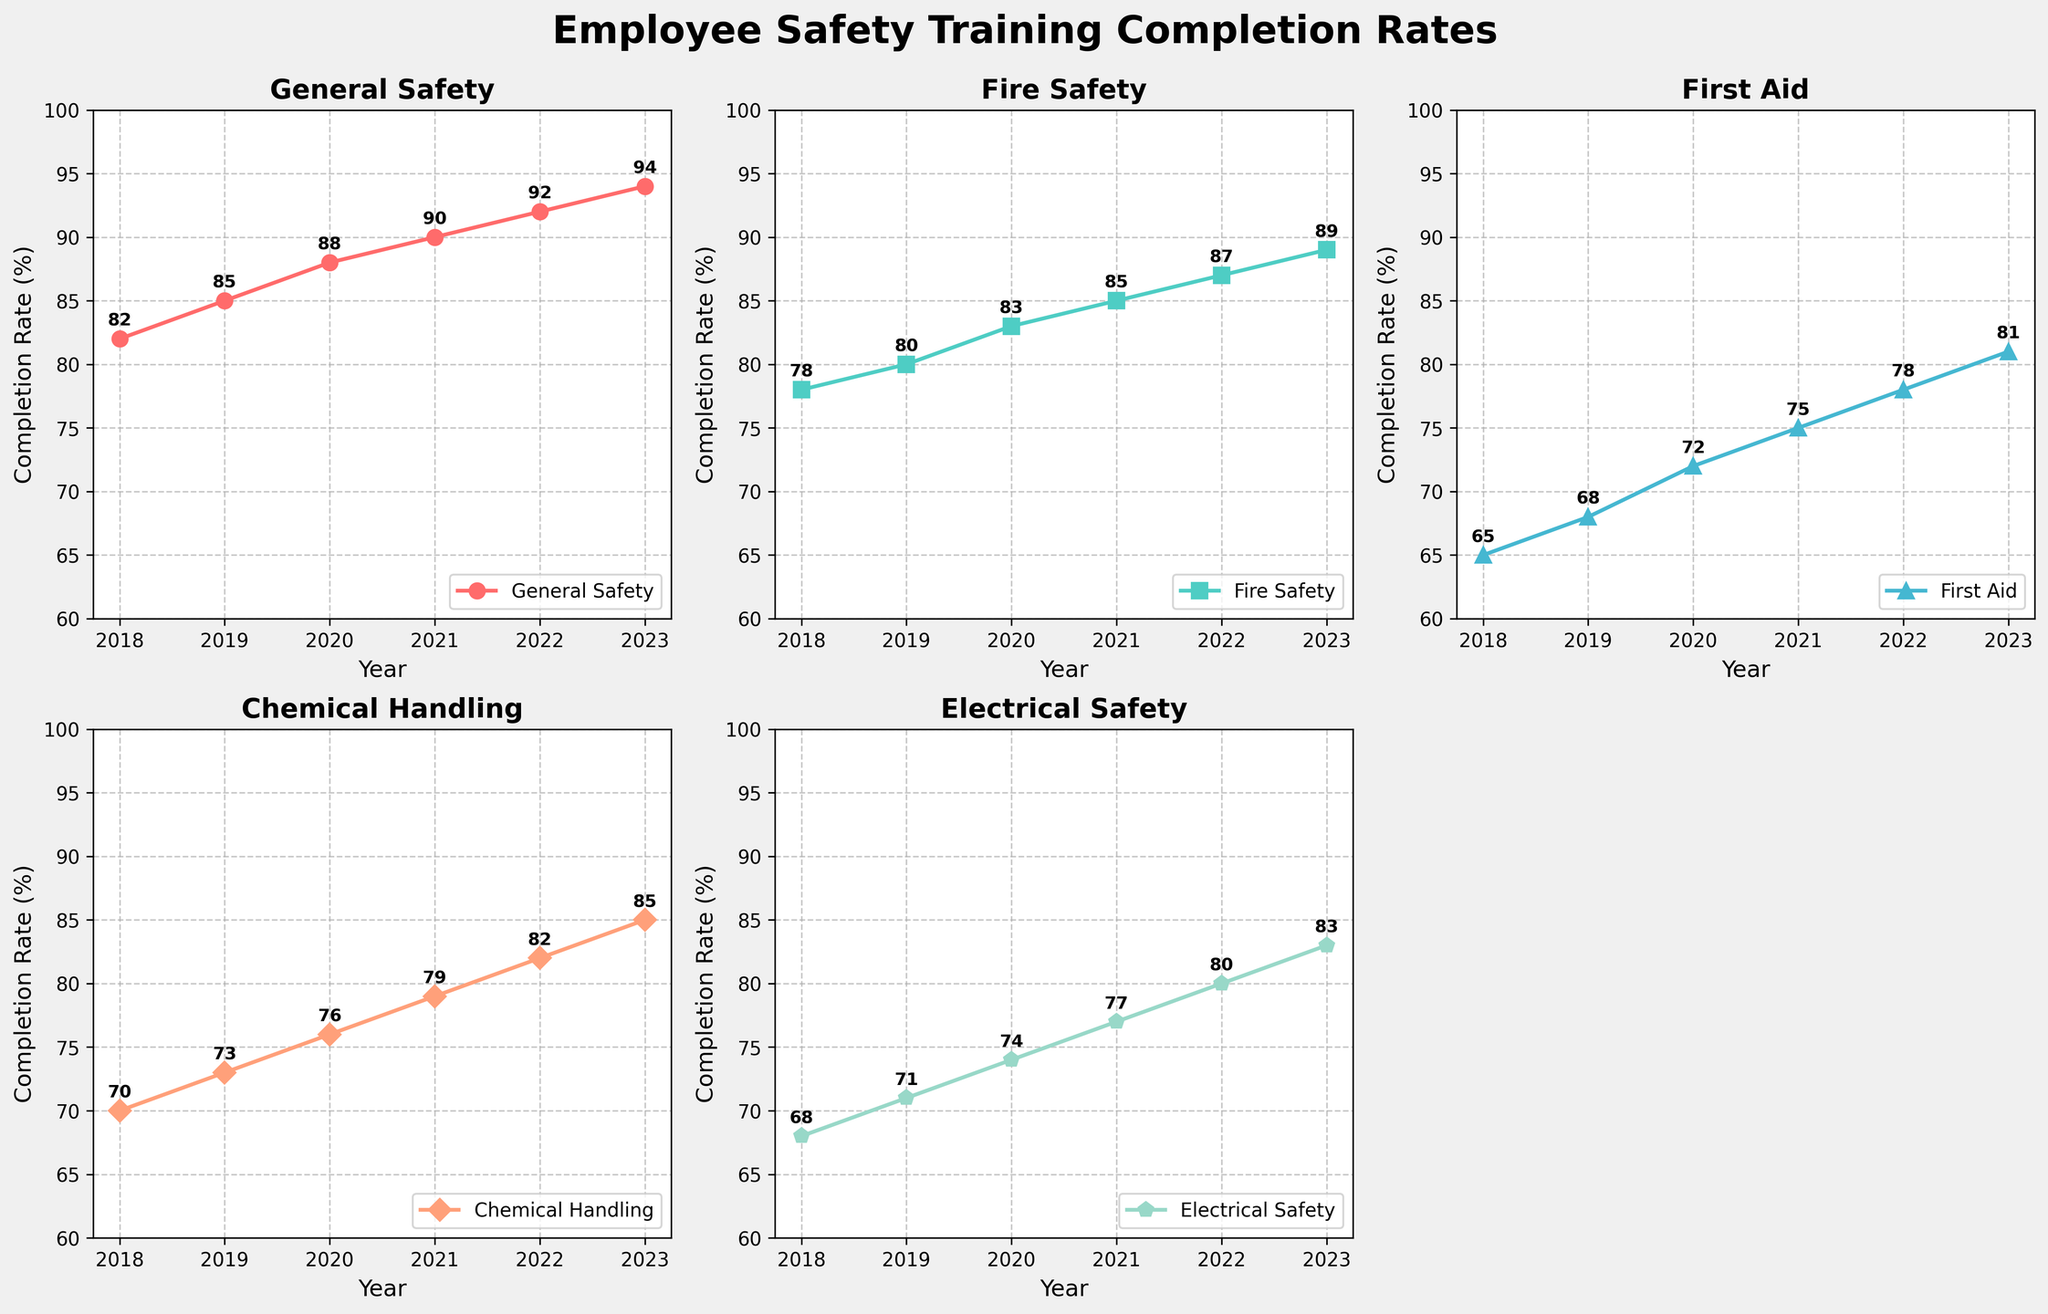How did the completion rates for "General Safety" trend over the years? The "General Safety" line on the plot shows an upward trend from 82% in 2018 to 94% in 2023. This indicates a steady improvement in completion rates for "General Safety" training over the years.
Answer: The completion rates for "General Safety" showed a steady upward trend Which safety training had the highest completion rate in 2023? Looking at the plot for 2023, the line with the highest value is "General Safety" at 94%.
Answer: General Safety Compare the completion rates of "First Aid" between 2018 and 2023. How much did it increase? The completion rate for "First Aid" was 65% in 2018 and increased to 81% in 2023. Therefore, the increase is 81% - 65% = 16%.
Answer: 16% Which safety training showed the most consistent increase over the years? By examining the slopes of the lines for all the trainings from 2018 to 2023, "General Safety" shows a consistent and steady increase each year.
Answer: General Safety How did the completion rate for "Fire Safety" in 2022 compare to "Electrical Safety" in 2020? The completion rate for "Fire Safety" in 2022 was 87%, and for "Electrical Safety" in 2020, it was 74%. Since 87% > 74%, "Fire Safety" in 2022 had a higher rate.
Answer: Fire Safety in 2022 had a higher rate Which safety training had the smallest increase in completion rates from 2018 to 2023? The smallest increase can be determined by finding the difference between the 2018 and 2023 completion rates for each training. "Electrical Safety" increased from 68% to 83%, which is an increase of 15%, the smallest among the categories.
Answer: Electrical Safety What was the average completion rate for "Chemical Handling" from 2018 to 2023? To calculate the average, add the completion rates for "Chemical Handling" from 2018 to 2023 and divide by the number of years: (70 + 73 + 76 + 79 + 82 + 85) / 6 = 77.5%.
Answer: 77.5% How many years did it take for "First Aid" training to surpass a 75% completion rate? By scanning the "First Aid" subplot, it exceeded 75% in the year 2021. Counting from 2018, it took 4 years (2018, 2019, 2020, and into 2021).
Answer: 4 years Between 2019 and 2020, which safety training course showed the largest increase in completion rates? Calculate the increase for each course: General Safety (85 to 88) = 3%, Fire Safety (80 to 83) = 3%, First Aid (68 to 72) = 4%, Chemical Handling (73 to 76) = 3%, Electrical Safety (71 to 74) = 3%. "First Aid" showed the largest increase of 4%.
Answer: First Aid 